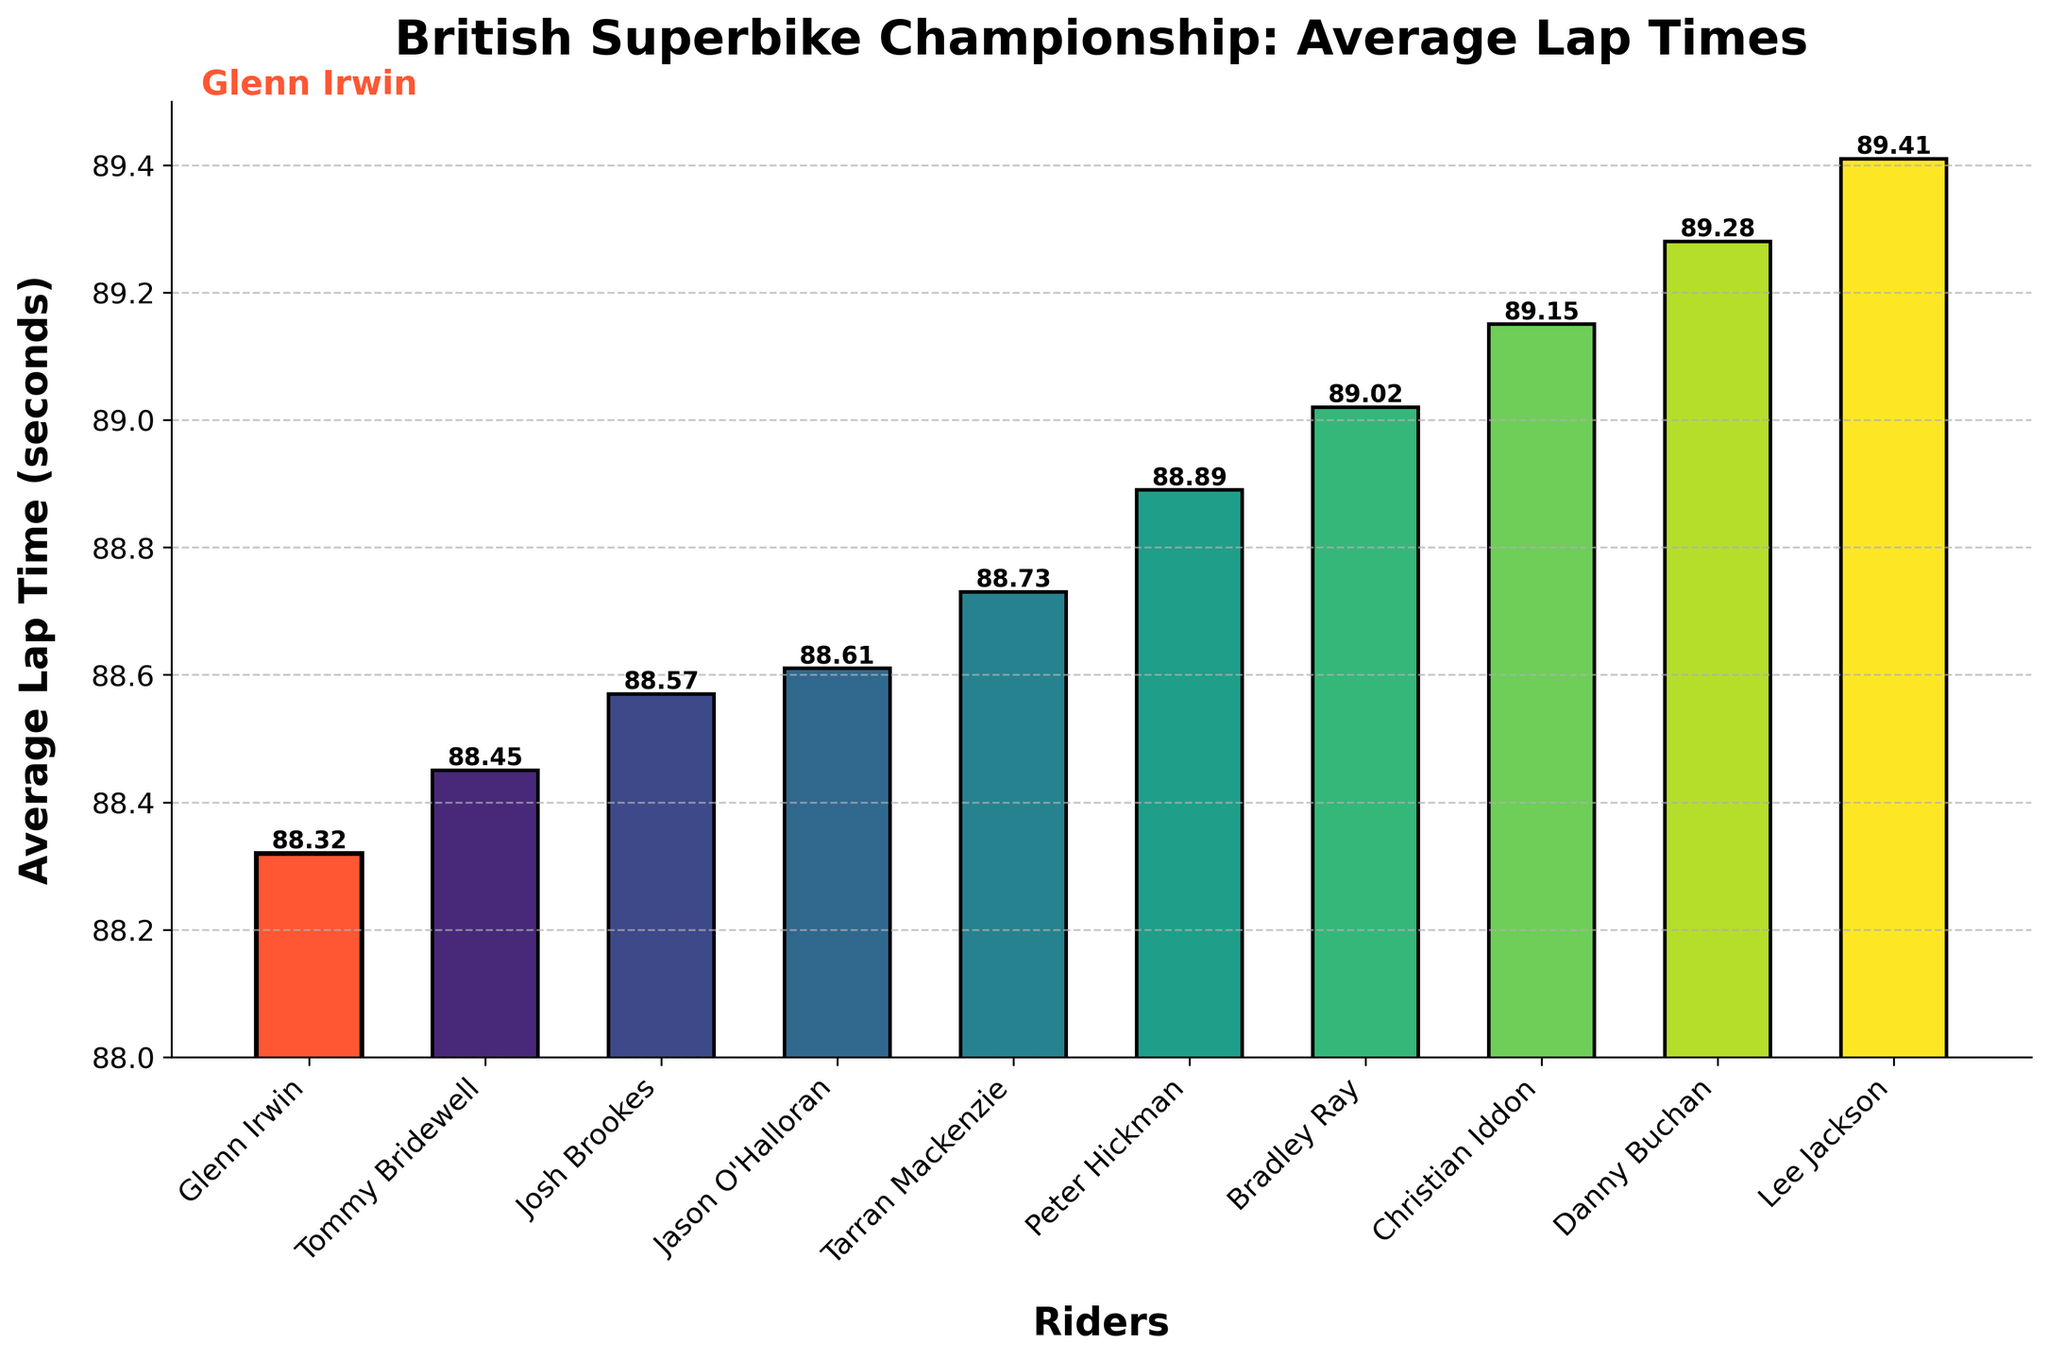How many riders have an average lap time greater than 89 seconds? Count the number of bars where the height (average lap time) exceeds 89 seconds. This includes Bradley Ray, Christian Iddon, Danny Buchan, and Lee Jackson.
Answer: 4 Which rider has the second fastest average lap time? First, identify the fastest rider, which is Glenn Irwin. The second fastest is Tommy Bridewell.
Answer: Tommy Bridewell Who has a higher lap time, Jason O'Halloran or Tarran Mackenzie, and by how much? Locate both Jason O'Halloran's and Tarran Mackenzie's bars. Jason's lap time is 88.61 seconds and Tarran's is 88.73 seconds. The difference is 88.73 - 88.61 = 0.12 seconds.
Answer: Tarran Mackenzie by 0.12 seconds Which competitors have an average lap time within 0.10 seconds of Glenn Irwin's time? Glenn Irwin's average lap time is 88.32 seconds. Riders within 88.22 to 88.42 seconds are Tommy Bridewell (88.45 seconds, but not within 0.10 seconds), so no competitors fit this criterion.
Answer: None What's the average lap time of the top 3 fastest riders? The top 3 fastest riders are Glenn Irwin (88.32), Tommy Bridewell (88.45), and Josh Brookes (88.57). Calculate (88.32 + 88.45 + 88.57) / 3 = 265.34 / 3 = 88.45 seconds.
Answer: 88.45 seconds Who is the slowest rider according to the chart, and what is their average lap time? Identify the rider with the tallest bar. Lee Jackson has the highest lap time of 89.41 seconds.
Answer: Lee Jackson, 89.41 seconds What is the difference in average lap time between the fastest and slowest rider? The fastest rider is Glenn Irwin at 88.32 seconds, and the slowest is Lee Jackson at 89.41 seconds. The difference is 89.41 - 88.32 = 1.09 seconds.
Answer: 1.09 seconds Which rider's bar is highlighted in a different color and why? The bar for Glenn Irwin is highlighted in a different (orange) color to emphasize he is the focus of the chart.
Answer: Glenn Irwin because he is the focus If Glenn Irwin's average lap time was reduced by 0.5 seconds, what would it be? Glenn Irwin's current lap time is 88.32 seconds. Subtract 0.5 from this: 88.32 - 0.5 = 87.82 seconds.
Answer: 87.82 seconds 